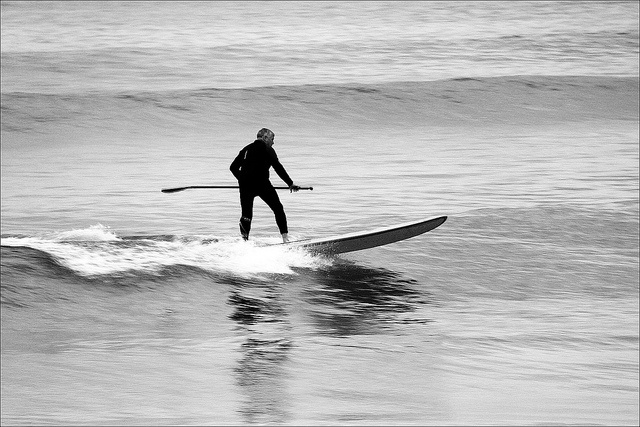Describe the objects in this image and their specific colors. I can see people in black, lightgray, gray, and darkgray tones and surfboard in black, lightgray, darkgray, and gray tones in this image. 